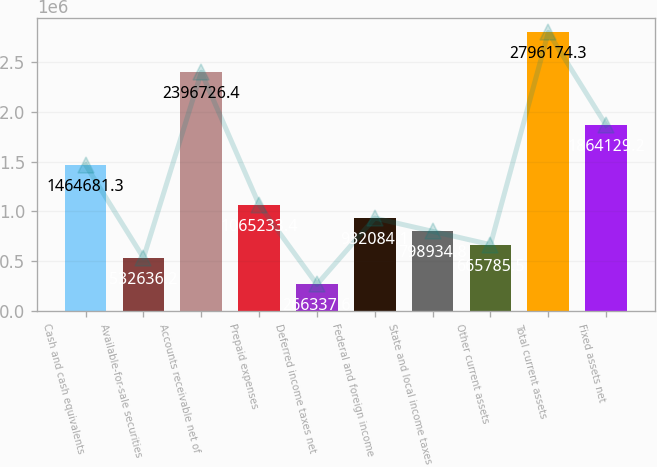Convert chart. <chart><loc_0><loc_0><loc_500><loc_500><bar_chart><fcel>Cash and cash equivalents<fcel>Available-for-sale securities<fcel>Accounts receivable net of<fcel>Prepaid expenses<fcel>Deferred income taxes net<fcel>Federal and foreign income<fcel>State and local income taxes<fcel>Other current assets<fcel>Total current assets<fcel>Fixed assets net<nl><fcel>1.46468e+06<fcel>532636<fcel>2.39673e+06<fcel>1.06523e+06<fcel>266338<fcel>932084<fcel>798935<fcel>665786<fcel>2.79617e+06<fcel>1.86413e+06<nl></chart> 